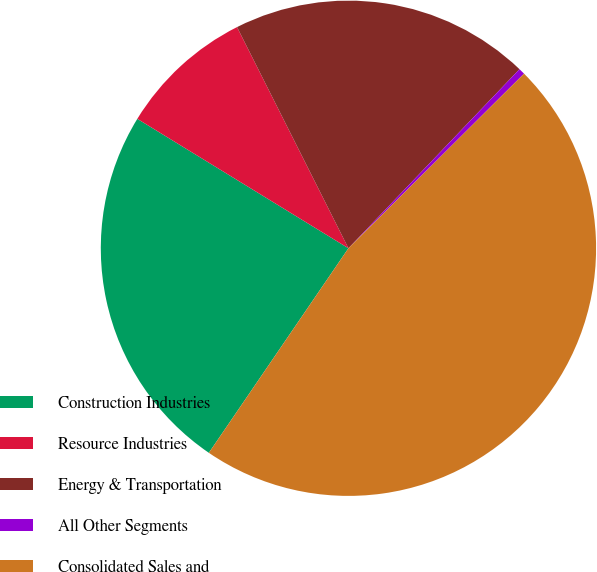Convert chart to OTSL. <chart><loc_0><loc_0><loc_500><loc_500><pie_chart><fcel>Construction Industries<fcel>Resource Industries<fcel>Energy & Transportation<fcel>All Other Segments<fcel>Consolidated Sales and<nl><fcel>24.22%<fcel>8.82%<fcel>19.56%<fcel>0.41%<fcel>46.98%<nl></chart> 